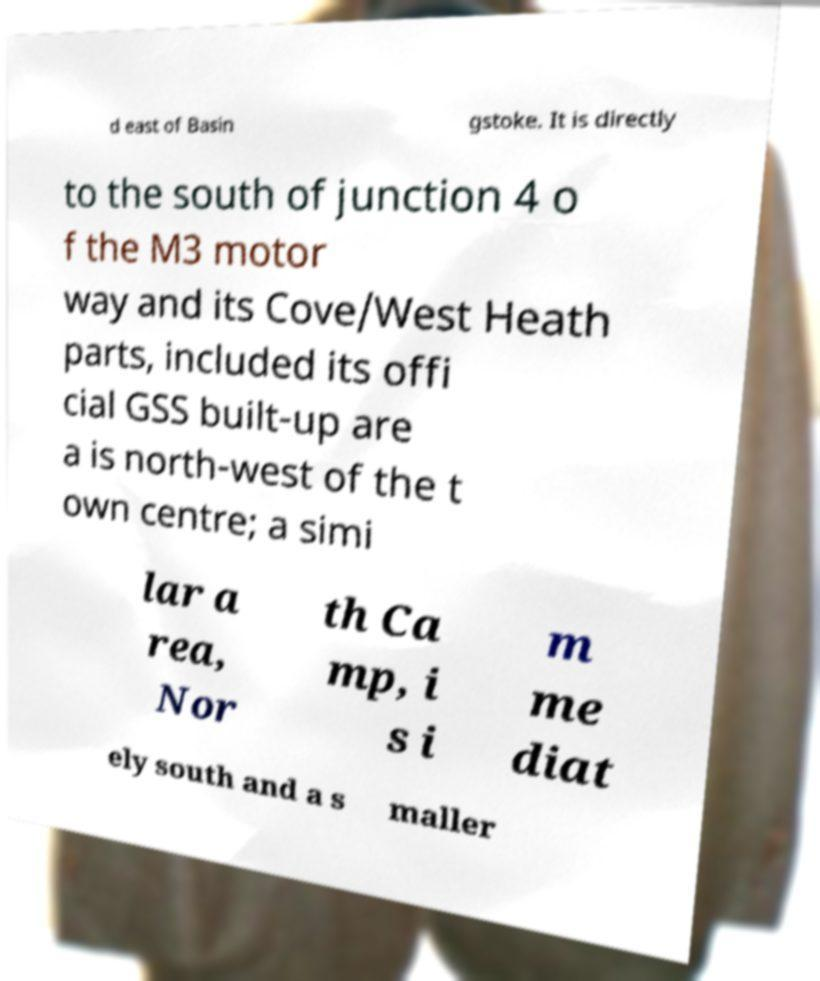Could you extract and type out the text from this image? d east of Basin gstoke. It is directly to the south of junction 4 o f the M3 motor way and its Cove/West Heath parts, included its offi cial GSS built-up are a is north-west of the t own centre; a simi lar a rea, Nor th Ca mp, i s i m me diat ely south and a s maller 